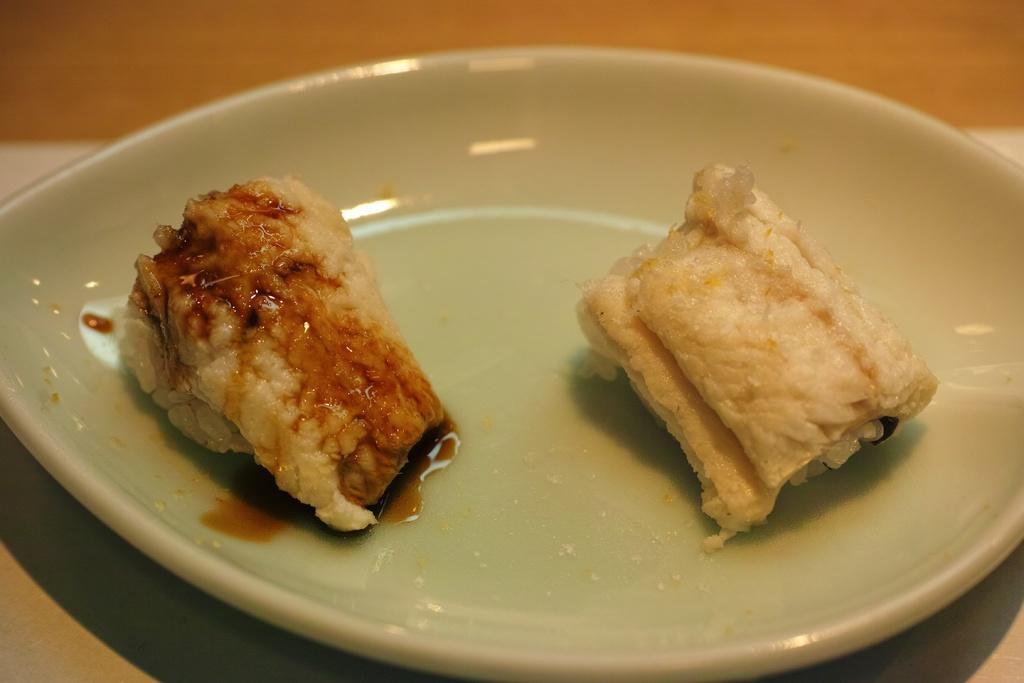Can you describe this image briefly? In this picture there is food on the plate. At the bottom it looks like a table. 